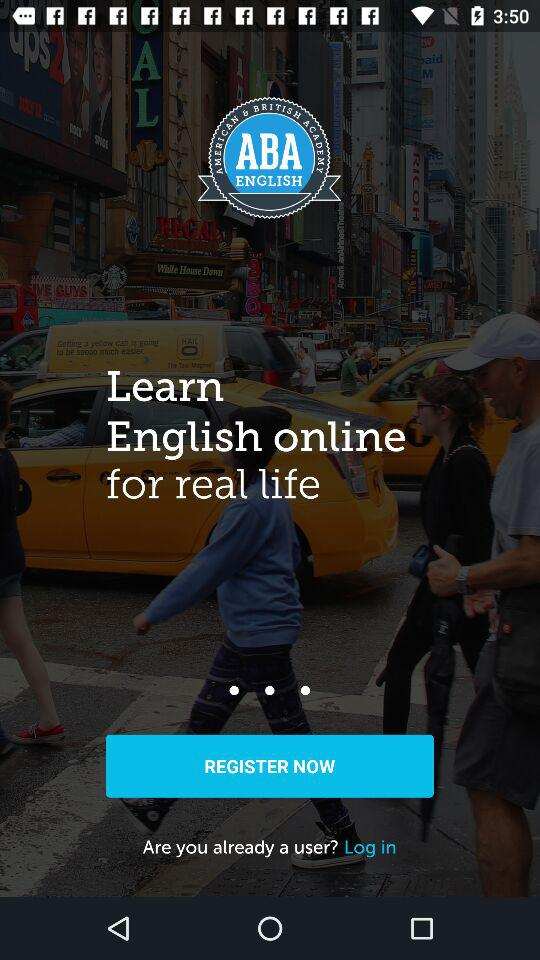What is the application name? The application name is "ABA ENGLISH". 